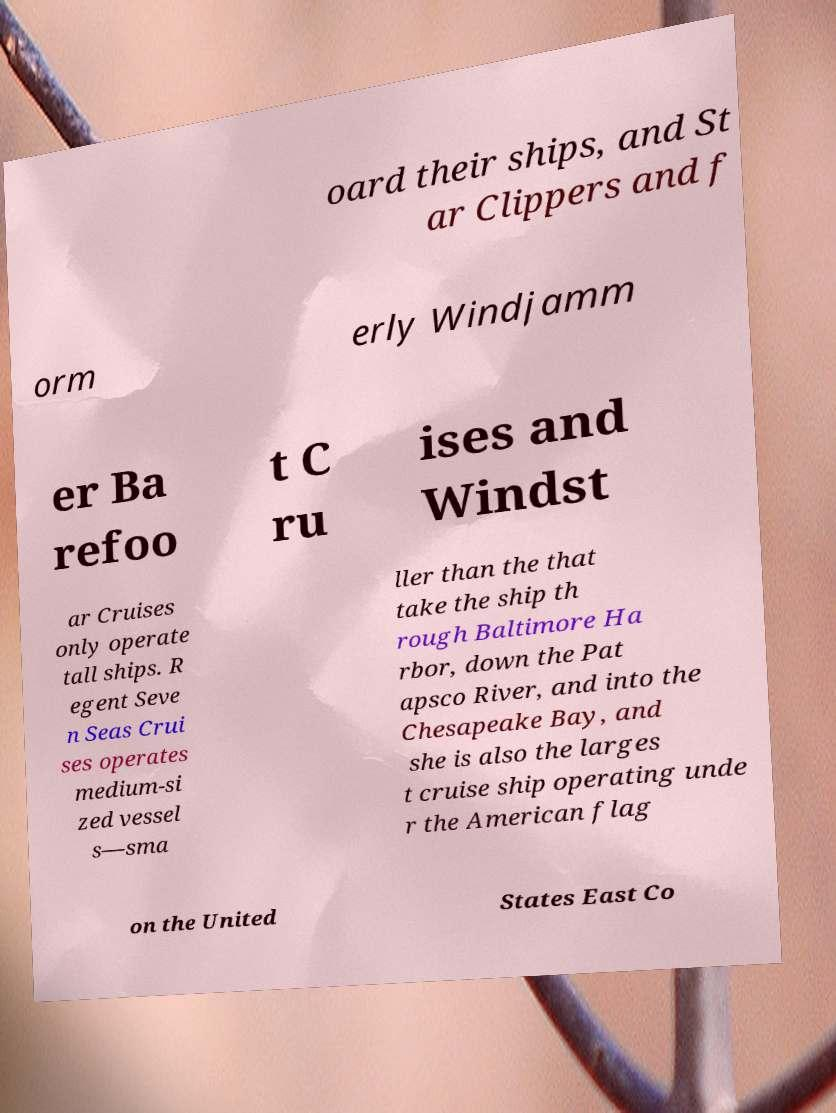I need the written content from this picture converted into text. Can you do that? oard their ships, and St ar Clippers and f orm erly Windjamm er Ba refoo t C ru ises and Windst ar Cruises only operate tall ships. R egent Seve n Seas Crui ses operates medium-si zed vessel s—sma ller than the that take the ship th rough Baltimore Ha rbor, down the Pat apsco River, and into the Chesapeake Bay, and she is also the larges t cruise ship operating unde r the American flag on the United States East Co 